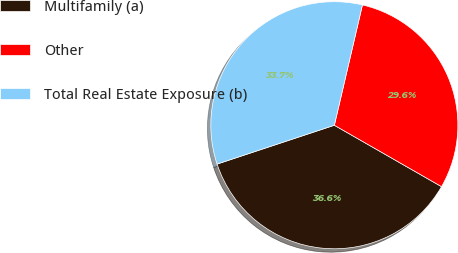<chart> <loc_0><loc_0><loc_500><loc_500><pie_chart><fcel>Multifamily (a)<fcel>Other<fcel>Total Real Estate Exposure (b)<nl><fcel>36.63%<fcel>29.63%<fcel>33.74%<nl></chart> 